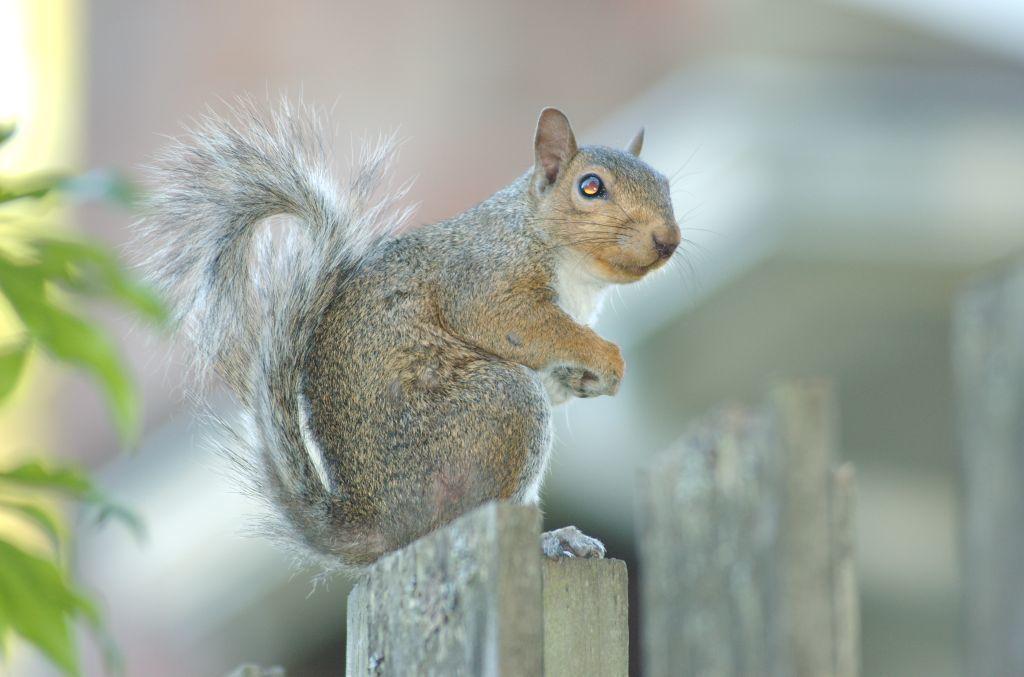Could you give a brief overview of what you see in this image? In this image we can see there is a squirrel sitting on the wooden pole behind that there is a plant. 